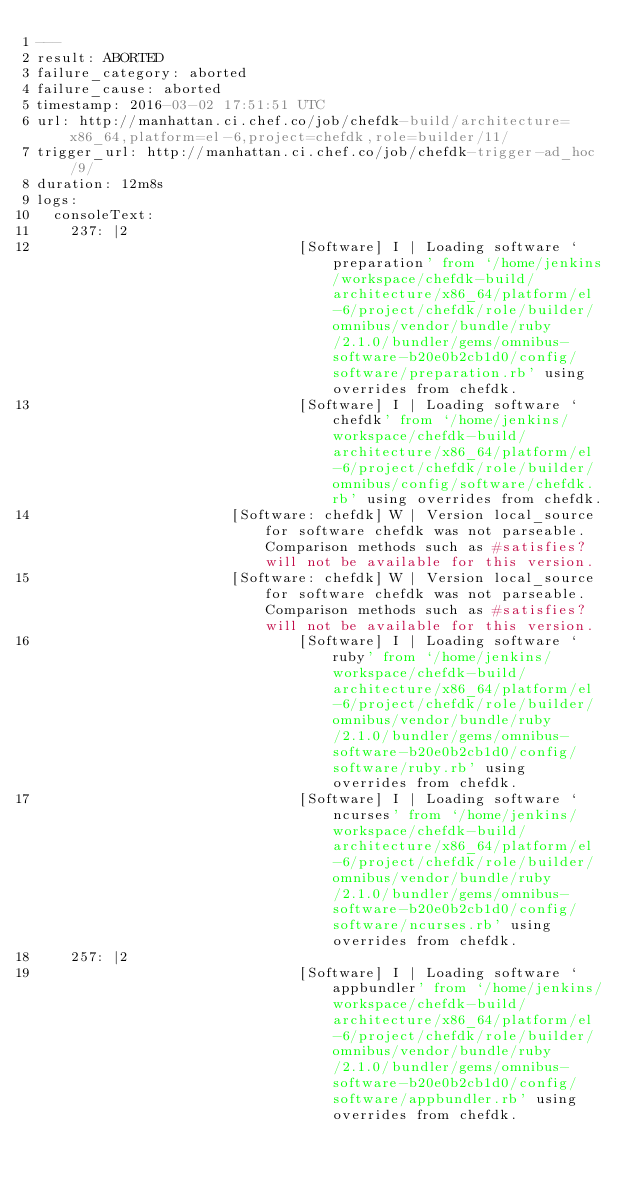Convert code to text. <code><loc_0><loc_0><loc_500><loc_500><_YAML_>---
result: ABORTED
failure_category: aborted
failure_cause: aborted
timestamp: 2016-03-02 17:51:51 UTC
url: http://manhattan.ci.chef.co/job/chefdk-build/architecture=x86_64,platform=el-6,project=chefdk,role=builder/11/
trigger_url: http://manhattan.ci.chef.co/job/chefdk-trigger-ad_hoc/9/
duration: 12m8s
logs:
  consoleText:
    237: |2
                               [Software] I | Loading software `preparation' from `/home/jenkins/workspace/chefdk-build/architecture/x86_64/platform/el-6/project/chefdk/role/builder/omnibus/vendor/bundle/ruby/2.1.0/bundler/gems/omnibus-software-b20e0b2cb1d0/config/software/preparation.rb' using overrides from chefdk.
                               [Software] I | Loading software `chefdk' from `/home/jenkins/workspace/chefdk-build/architecture/x86_64/platform/el-6/project/chefdk/role/builder/omnibus/config/software/chefdk.rb' using overrides from chefdk.
                       [Software: chefdk] W | Version local_source for software chefdk was not parseable. Comparison methods such as #satisfies? will not be available for this version.
                       [Software: chefdk] W | Version local_source for software chefdk was not parseable. Comparison methods such as #satisfies? will not be available for this version.
                               [Software] I | Loading software `ruby' from `/home/jenkins/workspace/chefdk-build/architecture/x86_64/platform/el-6/project/chefdk/role/builder/omnibus/vendor/bundle/ruby/2.1.0/bundler/gems/omnibus-software-b20e0b2cb1d0/config/software/ruby.rb' using overrides from chefdk.
                               [Software] I | Loading software `ncurses' from `/home/jenkins/workspace/chefdk-build/architecture/x86_64/platform/el-6/project/chefdk/role/builder/omnibus/vendor/bundle/ruby/2.1.0/bundler/gems/omnibus-software-b20e0b2cb1d0/config/software/ncurses.rb' using overrides from chefdk.
    257: |2
                               [Software] I | Loading software `appbundler' from `/home/jenkins/workspace/chefdk-build/architecture/x86_64/platform/el-6/project/chefdk/role/builder/omnibus/vendor/bundle/ruby/2.1.0/bundler/gems/omnibus-software-b20e0b2cb1d0/config/software/appbundler.rb' using overrides from chefdk.</code> 